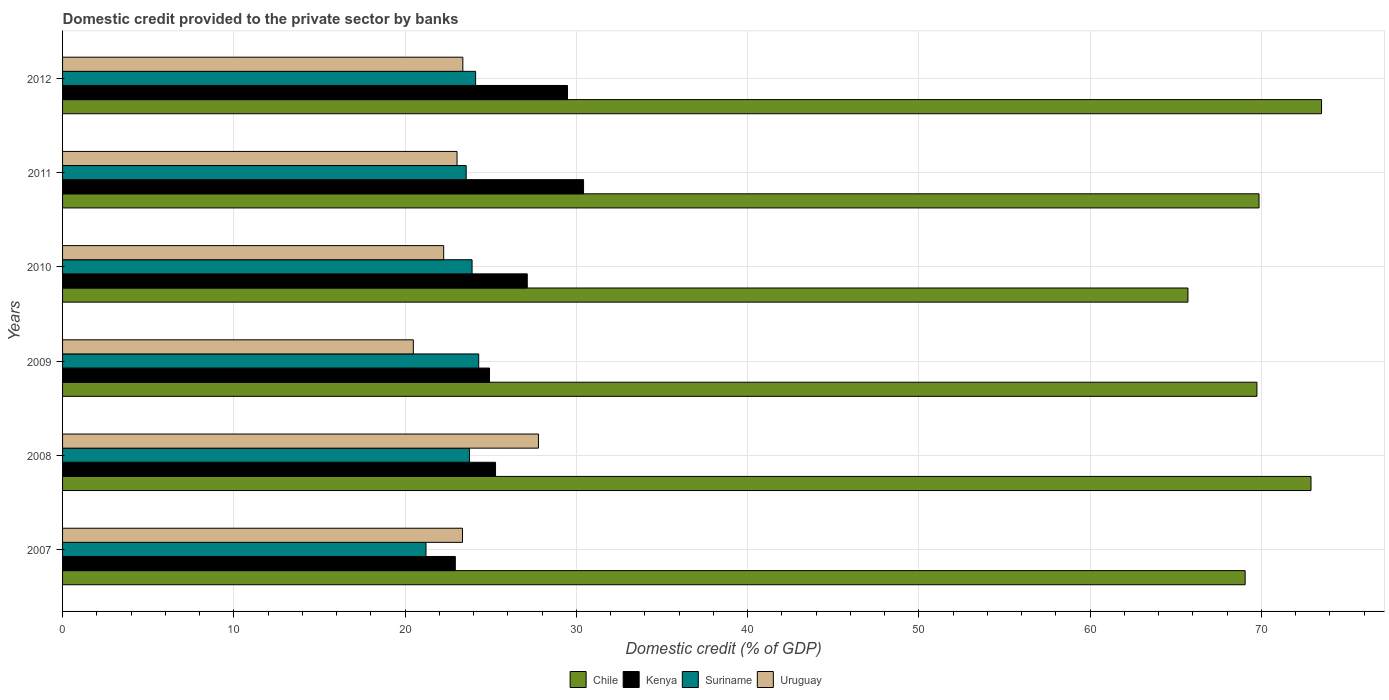Are the number of bars per tick equal to the number of legend labels?
Make the answer very short. Yes. In how many cases, is the number of bars for a given year not equal to the number of legend labels?
Give a very brief answer. 0. What is the domestic credit provided to the private sector by banks in Suriname in 2008?
Give a very brief answer. 23.76. Across all years, what is the maximum domestic credit provided to the private sector by banks in Kenya?
Provide a succinct answer. 30.42. Across all years, what is the minimum domestic credit provided to the private sector by banks in Kenya?
Make the answer very short. 22.93. In which year was the domestic credit provided to the private sector by banks in Chile minimum?
Offer a very short reply. 2010. What is the total domestic credit provided to the private sector by banks in Chile in the graph?
Keep it short and to the point. 420.77. What is the difference between the domestic credit provided to the private sector by banks in Chile in 2008 and that in 2012?
Offer a terse response. -0.62. What is the difference between the domestic credit provided to the private sector by banks in Chile in 2010 and the domestic credit provided to the private sector by banks in Suriname in 2008?
Offer a very short reply. 41.95. What is the average domestic credit provided to the private sector by banks in Suriname per year?
Keep it short and to the point. 23.48. In the year 2012, what is the difference between the domestic credit provided to the private sector by banks in Kenya and domestic credit provided to the private sector by banks in Suriname?
Provide a succinct answer. 5.37. What is the ratio of the domestic credit provided to the private sector by banks in Kenya in 2009 to that in 2011?
Keep it short and to the point. 0.82. Is the domestic credit provided to the private sector by banks in Kenya in 2007 less than that in 2009?
Offer a very short reply. Yes. Is the difference between the domestic credit provided to the private sector by banks in Kenya in 2007 and 2009 greater than the difference between the domestic credit provided to the private sector by banks in Suriname in 2007 and 2009?
Give a very brief answer. Yes. What is the difference between the highest and the second highest domestic credit provided to the private sector by banks in Kenya?
Your response must be concise. 0.94. What is the difference between the highest and the lowest domestic credit provided to the private sector by banks in Uruguay?
Your response must be concise. 7.31. Is it the case that in every year, the sum of the domestic credit provided to the private sector by banks in Uruguay and domestic credit provided to the private sector by banks in Chile is greater than the sum of domestic credit provided to the private sector by banks in Kenya and domestic credit provided to the private sector by banks in Suriname?
Your answer should be very brief. Yes. What does the 4th bar from the top in 2008 represents?
Keep it short and to the point. Chile. What does the 4th bar from the bottom in 2008 represents?
Ensure brevity in your answer.  Uruguay. Is it the case that in every year, the sum of the domestic credit provided to the private sector by banks in Kenya and domestic credit provided to the private sector by banks in Suriname is greater than the domestic credit provided to the private sector by banks in Uruguay?
Provide a short and direct response. Yes. Does the graph contain any zero values?
Provide a short and direct response. No. Does the graph contain grids?
Your response must be concise. Yes. Where does the legend appear in the graph?
Keep it short and to the point. Bottom center. How many legend labels are there?
Offer a terse response. 4. How are the legend labels stacked?
Ensure brevity in your answer.  Horizontal. What is the title of the graph?
Your answer should be compact. Domestic credit provided to the private sector by banks. What is the label or title of the X-axis?
Offer a very short reply. Domestic credit (% of GDP). What is the label or title of the Y-axis?
Your answer should be compact. Years. What is the Domestic credit (% of GDP) of Chile in 2007?
Keep it short and to the point. 69.05. What is the Domestic credit (% of GDP) in Kenya in 2007?
Provide a succinct answer. 22.93. What is the Domestic credit (% of GDP) in Suriname in 2007?
Keep it short and to the point. 21.22. What is the Domestic credit (% of GDP) in Uruguay in 2007?
Your response must be concise. 23.35. What is the Domestic credit (% of GDP) in Chile in 2008?
Your response must be concise. 72.9. What is the Domestic credit (% of GDP) of Kenya in 2008?
Your response must be concise. 25.28. What is the Domestic credit (% of GDP) in Suriname in 2008?
Ensure brevity in your answer.  23.76. What is the Domestic credit (% of GDP) of Uruguay in 2008?
Provide a short and direct response. 27.79. What is the Domestic credit (% of GDP) of Chile in 2009?
Offer a very short reply. 69.74. What is the Domestic credit (% of GDP) of Kenya in 2009?
Provide a succinct answer. 24.93. What is the Domestic credit (% of GDP) in Suriname in 2009?
Provide a short and direct response. 24.3. What is the Domestic credit (% of GDP) of Uruguay in 2009?
Give a very brief answer. 20.48. What is the Domestic credit (% of GDP) of Chile in 2010?
Ensure brevity in your answer.  65.71. What is the Domestic credit (% of GDP) of Kenya in 2010?
Ensure brevity in your answer.  27.13. What is the Domestic credit (% of GDP) in Suriname in 2010?
Provide a short and direct response. 23.91. What is the Domestic credit (% of GDP) of Uruguay in 2010?
Offer a very short reply. 22.25. What is the Domestic credit (% of GDP) in Chile in 2011?
Ensure brevity in your answer.  69.86. What is the Domestic credit (% of GDP) in Kenya in 2011?
Provide a succinct answer. 30.42. What is the Domestic credit (% of GDP) of Suriname in 2011?
Make the answer very short. 23.57. What is the Domestic credit (% of GDP) of Uruguay in 2011?
Give a very brief answer. 23.03. What is the Domestic credit (% of GDP) of Chile in 2012?
Offer a terse response. 73.51. What is the Domestic credit (% of GDP) in Kenya in 2012?
Give a very brief answer. 29.48. What is the Domestic credit (% of GDP) in Suriname in 2012?
Provide a succinct answer. 24.12. What is the Domestic credit (% of GDP) of Uruguay in 2012?
Provide a succinct answer. 23.37. Across all years, what is the maximum Domestic credit (% of GDP) in Chile?
Offer a very short reply. 73.51. Across all years, what is the maximum Domestic credit (% of GDP) of Kenya?
Your answer should be compact. 30.42. Across all years, what is the maximum Domestic credit (% of GDP) of Suriname?
Your response must be concise. 24.3. Across all years, what is the maximum Domestic credit (% of GDP) in Uruguay?
Keep it short and to the point. 27.79. Across all years, what is the minimum Domestic credit (% of GDP) of Chile?
Offer a very short reply. 65.71. Across all years, what is the minimum Domestic credit (% of GDP) of Kenya?
Offer a very short reply. 22.93. Across all years, what is the minimum Domestic credit (% of GDP) in Suriname?
Your response must be concise. 21.22. Across all years, what is the minimum Domestic credit (% of GDP) of Uruguay?
Make the answer very short. 20.48. What is the total Domestic credit (% of GDP) of Chile in the graph?
Your answer should be compact. 420.77. What is the total Domestic credit (% of GDP) in Kenya in the graph?
Your answer should be very brief. 160.18. What is the total Domestic credit (% of GDP) of Suriname in the graph?
Your response must be concise. 140.87. What is the total Domestic credit (% of GDP) in Uruguay in the graph?
Your answer should be very brief. 140.28. What is the difference between the Domestic credit (% of GDP) in Chile in 2007 and that in 2008?
Your answer should be very brief. -3.85. What is the difference between the Domestic credit (% of GDP) in Kenya in 2007 and that in 2008?
Give a very brief answer. -2.35. What is the difference between the Domestic credit (% of GDP) of Suriname in 2007 and that in 2008?
Your answer should be very brief. -2.54. What is the difference between the Domestic credit (% of GDP) of Uruguay in 2007 and that in 2008?
Ensure brevity in your answer.  -4.44. What is the difference between the Domestic credit (% of GDP) in Chile in 2007 and that in 2009?
Your answer should be compact. -0.69. What is the difference between the Domestic credit (% of GDP) in Kenya in 2007 and that in 2009?
Keep it short and to the point. -2. What is the difference between the Domestic credit (% of GDP) of Suriname in 2007 and that in 2009?
Your answer should be compact. -3.08. What is the difference between the Domestic credit (% of GDP) of Uruguay in 2007 and that in 2009?
Ensure brevity in your answer.  2.87. What is the difference between the Domestic credit (% of GDP) of Chile in 2007 and that in 2010?
Offer a very short reply. 3.34. What is the difference between the Domestic credit (% of GDP) in Kenya in 2007 and that in 2010?
Offer a very short reply. -4.2. What is the difference between the Domestic credit (% of GDP) of Suriname in 2007 and that in 2010?
Your response must be concise. -2.69. What is the difference between the Domestic credit (% of GDP) of Uruguay in 2007 and that in 2010?
Offer a very short reply. 1.1. What is the difference between the Domestic credit (% of GDP) in Chile in 2007 and that in 2011?
Give a very brief answer. -0.81. What is the difference between the Domestic credit (% of GDP) of Kenya in 2007 and that in 2011?
Offer a terse response. -7.49. What is the difference between the Domestic credit (% of GDP) in Suriname in 2007 and that in 2011?
Your answer should be compact. -2.35. What is the difference between the Domestic credit (% of GDP) of Uruguay in 2007 and that in 2011?
Give a very brief answer. 0.32. What is the difference between the Domestic credit (% of GDP) of Chile in 2007 and that in 2012?
Provide a succinct answer. -4.46. What is the difference between the Domestic credit (% of GDP) in Kenya in 2007 and that in 2012?
Provide a short and direct response. -6.55. What is the difference between the Domestic credit (% of GDP) in Suriname in 2007 and that in 2012?
Ensure brevity in your answer.  -2.9. What is the difference between the Domestic credit (% of GDP) in Uruguay in 2007 and that in 2012?
Your answer should be compact. -0.02. What is the difference between the Domestic credit (% of GDP) in Chile in 2008 and that in 2009?
Offer a very short reply. 3.16. What is the difference between the Domestic credit (% of GDP) in Kenya in 2008 and that in 2009?
Provide a short and direct response. 0.35. What is the difference between the Domestic credit (% of GDP) in Suriname in 2008 and that in 2009?
Your answer should be very brief. -0.54. What is the difference between the Domestic credit (% of GDP) of Uruguay in 2008 and that in 2009?
Keep it short and to the point. 7.31. What is the difference between the Domestic credit (% of GDP) of Chile in 2008 and that in 2010?
Your response must be concise. 7.18. What is the difference between the Domestic credit (% of GDP) in Kenya in 2008 and that in 2010?
Give a very brief answer. -1.85. What is the difference between the Domestic credit (% of GDP) in Suriname in 2008 and that in 2010?
Ensure brevity in your answer.  -0.15. What is the difference between the Domestic credit (% of GDP) in Uruguay in 2008 and that in 2010?
Provide a succinct answer. 5.53. What is the difference between the Domestic credit (% of GDP) of Chile in 2008 and that in 2011?
Make the answer very short. 3.03. What is the difference between the Domestic credit (% of GDP) in Kenya in 2008 and that in 2011?
Give a very brief answer. -5.14. What is the difference between the Domestic credit (% of GDP) of Suriname in 2008 and that in 2011?
Your answer should be very brief. 0.19. What is the difference between the Domestic credit (% of GDP) of Uruguay in 2008 and that in 2011?
Make the answer very short. 4.75. What is the difference between the Domestic credit (% of GDP) in Chile in 2008 and that in 2012?
Offer a terse response. -0.62. What is the difference between the Domestic credit (% of GDP) of Kenya in 2008 and that in 2012?
Provide a short and direct response. -4.2. What is the difference between the Domestic credit (% of GDP) in Suriname in 2008 and that in 2012?
Offer a very short reply. -0.36. What is the difference between the Domestic credit (% of GDP) of Uruguay in 2008 and that in 2012?
Provide a short and direct response. 4.42. What is the difference between the Domestic credit (% of GDP) of Chile in 2009 and that in 2010?
Make the answer very short. 4.03. What is the difference between the Domestic credit (% of GDP) in Kenya in 2009 and that in 2010?
Your response must be concise. -2.2. What is the difference between the Domestic credit (% of GDP) in Suriname in 2009 and that in 2010?
Keep it short and to the point. 0.39. What is the difference between the Domestic credit (% of GDP) of Uruguay in 2009 and that in 2010?
Provide a succinct answer. -1.77. What is the difference between the Domestic credit (% of GDP) of Chile in 2009 and that in 2011?
Your answer should be compact. -0.12. What is the difference between the Domestic credit (% of GDP) of Kenya in 2009 and that in 2011?
Make the answer very short. -5.49. What is the difference between the Domestic credit (% of GDP) of Suriname in 2009 and that in 2011?
Ensure brevity in your answer.  0.73. What is the difference between the Domestic credit (% of GDP) of Uruguay in 2009 and that in 2011?
Offer a very short reply. -2.55. What is the difference between the Domestic credit (% of GDP) in Chile in 2009 and that in 2012?
Keep it short and to the point. -3.77. What is the difference between the Domestic credit (% of GDP) of Kenya in 2009 and that in 2012?
Offer a terse response. -4.55. What is the difference between the Domestic credit (% of GDP) in Suriname in 2009 and that in 2012?
Ensure brevity in your answer.  0.18. What is the difference between the Domestic credit (% of GDP) of Uruguay in 2009 and that in 2012?
Provide a succinct answer. -2.89. What is the difference between the Domestic credit (% of GDP) in Chile in 2010 and that in 2011?
Provide a succinct answer. -4.15. What is the difference between the Domestic credit (% of GDP) of Kenya in 2010 and that in 2011?
Provide a succinct answer. -3.29. What is the difference between the Domestic credit (% of GDP) in Suriname in 2010 and that in 2011?
Your answer should be very brief. 0.34. What is the difference between the Domestic credit (% of GDP) of Uruguay in 2010 and that in 2011?
Give a very brief answer. -0.78. What is the difference between the Domestic credit (% of GDP) in Chile in 2010 and that in 2012?
Offer a very short reply. -7.8. What is the difference between the Domestic credit (% of GDP) in Kenya in 2010 and that in 2012?
Keep it short and to the point. -2.35. What is the difference between the Domestic credit (% of GDP) in Suriname in 2010 and that in 2012?
Your answer should be compact. -0.21. What is the difference between the Domestic credit (% of GDP) of Uruguay in 2010 and that in 2012?
Your response must be concise. -1.12. What is the difference between the Domestic credit (% of GDP) in Chile in 2011 and that in 2012?
Keep it short and to the point. -3.65. What is the difference between the Domestic credit (% of GDP) in Kenya in 2011 and that in 2012?
Offer a very short reply. 0.94. What is the difference between the Domestic credit (% of GDP) of Suriname in 2011 and that in 2012?
Your response must be concise. -0.55. What is the difference between the Domestic credit (% of GDP) in Uruguay in 2011 and that in 2012?
Offer a very short reply. -0.34. What is the difference between the Domestic credit (% of GDP) in Chile in 2007 and the Domestic credit (% of GDP) in Kenya in 2008?
Your response must be concise. 43.77. What is the difference between the Domestic credit (% of GDP) of Chile in 2007 and the Domestic credit (% of GDP) of Suriname in 2008?
Make the answer very short. 45.29. What is the difference between the Domestic credit (% of GDP) in Chile in 2007 and the Domestic credit (% of GDP) in Uruguay in 2008?
Make the answer very short. 41.26. What is the difference between the Domestic credit (% of GDP) in Kenya in 2007 and the Domestic credit (% of GDP) in Suriname in 2008?
Provide a succinct answer. -0.82. What is the difference between the Domestic credit (% of GDP) in Kenya in 2007 and the Domestic credit (% of GDP) in Uruguay in 2008?
Offer a terse response. -4.85. What is the difference between the Domestic credit (% of GDP) of Suriname in 2007 and the Domestic credit (% of GDP) of Uruguay in 2008?
Offer a very short reply. -6.57. What is the difference between the Domestic credit (% of GDP) of Chile in 2007 and the Domestic credit (% of GDP) of Kenya in 2009?
Offer a very short reply. 44.12. What is the difference between the Domestic credit (% of GDP) in Chile in 2007 and the Domestic credit (% of GDP) in Suriname in 2009?
Your answer should be compact. 44.75. What is the difference between the Domestic credit (% of GDP) of Chile in 2007 and the Domestic credit (% of GDP) of Uruguay in 2009?
Make the answer very short. 48.57. What is the difference between the Domestic credit (% of GDP) of Kenya in 2007 and the Domestic credit (% of GDP) of Suriname in 2009?
Offer a very short reply. -1.36. What is the difference between the Domestic credit (% of GDP) in Kenya in 2007 and the Domestic credit (% of GDP) in Uruguay in 2009?
Make the answer very short. 2.45. What is the difference between the Domestic credit (% of GDP) of Suriname in 2007 and the Domestic credit (% of GDP) of Uruguay in 2009?
Offer a terse response. 0.74. What is the difference between the Domestic credit (% of GDP) in Chile in 2007 and the Domestic credit (% of GDP) in Kenya in 2010?
Offer a terse response. 41.92. What is the difference between the Domestic credit (% of GDP) in Chile in 2007 and the Domestic credit (% of GDP) in Suriname in 2010?
Your answer should be compact. 45.14. What is the difference between the Domestic credit (% of GDP) in Chile in 2007 and the Domestic credit (% of GDP) in Uruguay in 2010?
Provide a short and direct response. 46.8. What is the difference between the Domestic credit (% of GDP) in Kenya in 2007 and the Domestic credit (% of GDP) in Suriname in 2010?
Make the answer very short. -0.98. What is the difference between the Domestic credit (% of GDP) in Kenya in 2007 and the Domestic credit (% of GDP) in Uruguay in 2010?
Offer a very short reply. 0.68. What is the difference between the Domestic credit (% of GDP) in Suriname in 2007 and the Domestic credit (% of GDP) in Uruguay in 2010?
Your response must be concise. -1.03. What is the difference between the Domestic credit (% of GDP) of Chile in 2007 and the Domestic credit (% of GDP) of Kenya in 2011?
Ensure brevity in your answer.  38.63. What is the difference between the Domestic credit (% of GDP) of Chile in 2007 and the Domestic credit (% of GDP) of Suriname in 2011?
Make the answer very short. 45.48. What is the difference between the Domestic credit (% of GDP) in Chile in 2007 and the Domestic credit (% of GDP) in Uruguay in 2011?
Provide a short and direct response. 46.02. What is the difference between the Domestic credit (% of GDP) in Kenya in 2007 and the Domestic credit (% of GDP) in Suriname in 2011?
Provide a succinct answer. -0.63. What is the difference between the Domestic credit (% of GDP) of Kenya in 2007 and the Domestic credit (% of GDP) of Uruguay in 2011?
Ensure brevity in your answer.  -0.1. What is the difference between the Domestic credit (% of GDP) of Suriname in 2007 and the Domestic credit (% of GDP) of Uruguay in 2011?
Give a very brief answer. -1.81. What is the difference between the Domestic credit (% of GDP) in Chile in 2007 and the Domestic credit (% of GDP) in Kenya in 2012?
Ensure brevity in your answer.  39.57. What is the difference between the Domestic credit (% of GDP) in Chile in 2007 and the Domestic credit (% of GDP) in Suriname in 2012?
Your answer should be compact. 44.93. What is the difference between the Domestic credit (% of GDP) in Chile in 2007 and the Domestic credit (% of GDP) in Uruguay in 2012?
Offer a very short reply. 45.68. What is the difference between the Domestic credit (% of GDP) of Kenya in 2007 and the Domestic credit (% of GDP) of Suriname in 2012?
Give a very brief answer. -1.19. What is the difference between the Domestic credit (% of GDP) of Kenya in 2007 and the Domestic credit (% of GDP) of Uruguay in 2012?
Your answer should be very brief. -0.44. What is the difference between the Domestic credit (% of GDP) in Suriname in 2007 and the Domestic credit (% of GDP) in Uruguay in 2012?
Your response must be concise. -2.15. What is the difference between the Domestic credit (% of GDP) in Chile in 2008 and the Domestic credit (% of GDP) in Kenya in 2009?
Provide a short and direct response. 47.97. What is the difference between the Domestic credit (% of GDP) of Chile in 2008 and the Domestic credit (% of GDP) of Suriname in 2009?
Provide a succinct answer. 48.6. What is the difference between the Domestic credit (% of GDP) in Chile in 2008 and the Domestic credit (% of GDP) in Uruguay in 2009?
Give a very brief answer. 52.41. What is the difference between the Domestic credit (% of GDP) of Kenya in 2008 and the Domestic credit (% of GDP) of Suriname in 2009?
Provide a short and direct response. 0.98. What is the difference between the Domestic credit (% of GDP) in Kenya in 2008 and the Domestic credit (% of GDP) in Uruguay in 2009?
Your answer should be very brief. 4.8. What is the difference between the Domestic credit (% of GDP) in Suriname in 2008 and the Domestic credit (% of GDP) in Uruguay in 2009?
Your answer should be very brief. 3.28. What is the difference between the Domestic credit (% of GDP) in Chile in 2008 and the Domestic credit (% of GDP) in Kenya in 2010?
Keep it short and to the point. 45.76. What is the difference between the Domestic credit (% of GDP) in Chile in 2008 and the Domestic credit (% of GDP) in Suriname in 2010?
Your answer should be very brief. 48.98. What is the difference between the Domestic credit (% of GDP) in Chile in 2008 and the Domestic credit (% of GDP) in Uruguay in 2010?
Give a very brief answer. 50.64. What is the difference between the Domestic credit (% of GDP) of Kenya in 2008 and the Domestic credit (% of GDP) of Suriname in 2010?
Your response must be concise. 1.37. What is the difference between the Domestic credit (% of GDP) of Kenya in 2008 and the Domestic credit (% of GDP) of Uruguay in 2010?
Provide a succinct answer. 3.03. What is the difference between the Domestic credit (% of GDP) in Suriname in 2008 and the Domestic credit (% of GDP) in Uruguay in 2010?
Your answer should be compact. 1.5. What is the difference between the Domestic credit (% of GDP) in Chile in 2008 and the Domestic credit (% of GDP) in Kenya in 2011?
Your answer should be very brief. 42.47. What is the difference between the Domestic credit (% of GDP) in Chile in 2008 and the Domestic credit (% of GDP) in Suriname in 2011?
Offer a very short reply. 49.33. What is the difference between the Domestic credit (% of GDP) of Chile in 2008 and the Domestic credit (% of GDP) of Uruguay in 2011?
Your answer should be compact. 49.86. What is the difference between the Domestic credit (% of GDP) in Kenya in 2008 and the Domestic credit (% of GDP) in Suriname in 2011?
Offer a very short reply. 1.71. What is the difference between the Domestic credit (% of GDP) of Kenya in 2008 and the Domestic credit (% of GDP) of Uruguay in 2011?
Your response must be concise. 2.25. What is the difference between the Domestic credit (% of GDP) in Suriname in 2008 and the Domestic credit (% of GDP) in Uruguay in 2011?
Your answer should be compact. 0.72. What is the difference between the Domestic credit (% of GDP) in Chile in 2008 and the Domestic credit (% of GDP) in Kenya in 2012?
Provide a short and direct response. 43.41. What is the difference between the Domestic credit (% of GDP) in Chile in 2008 and the Domestic credit (% of GDP) in Suriname in 2012?
Your answer should be very brief. 48.78. What is the difference between the Domestic credit (% of GDP) of Chile in 2008 and the Domestic credit (% of GDP) of Uruguay in 2012?
Offer a very short reply. 49.52. What is the difference between the Domestic credit (% of GDP) of Kenya in 2008 and the Domestic credit (% of GDP) of Suriname in 2012?
Offer a terse response. 1.16. What is the difference between the Domestic credit (% of GDP) of Kenya in 2008 and the Domestic credit (% of GDP) of Uruguay in 2012?
Your answer should be very brief. 1.91. What is the difference between the Domestic credit (% of GDP) in Suriname in 2008 and the Domestic credit (% of GDP) in Uruguay in 2012?
Keep it short and to the point. 0.39. What is the difference between the Domestic credit (% of GDP) in Chile in 2009 and the Domestic credit (% of GDP) in Kenya in 2010?
Your response must be concise. 42.6. What is the difference between the Domestic credit (% of GDP) of Chile in 2009 and the Domestic credit (% of GDP) of Suriname in 2010?
Provide a short and direct response. 45.83. What is the difference between the Domestic credit (% of GDP) in Chile in 2009 and the Domestic credit (% of GDP) in Uruguay in 2010?
Your answer should be compact. 47.49. What is the difference between the Domestic credit (% of GDP) of Kenya in 2009 and the Domestic credit (% of GDP) of Suriname in 2010?
Offer a very short reply. 1.02. What is the difference between the Domestic credit (% of GDP) in Kenya in 2009 and the Domestic credit (% of GDP) in Uruguay in 2010?
Your answer should be compact. 2.68. What is the difference between the Domestic credit (% of GDP) of Suriname in 2009 and the Domestic credit (% of GDP) of Uruguay in 2010?
Your response must be concise. 2.04. What is the difference between the Domestic credit (% of GDP) of Chile in 2009 and the Domestic credit (% of GDP) of Kenya in 2011?
Your response must be concise. 39.32. What is the difference between the Domestic credit (% of GDP) in Chile in 2009 and the Domestic credit (% of GDP) in Suriname in 2011?
Make the answer very short. 46.17. What is the difference between the Domestic credit (% of GDP) in Chile in 2009 and the Domestic credit (% of GDP) in Uruguay in 2011?
Your response must be concise. 46.71. What is the difference between the Domestic credit (% of GDP) in Kenya in 2009 and the Domestic credit (% of GDP) in Suriname in 2011?
Your answer should be compact. 1.36. What is the difference between the Domestic credit (% of GDP) in Kenya in 2009 and the Domestic credit (% of GDP) in Uruguay in 2011?
Offer a terse response. 1.9. What is the difference between the Domestic credit (% of GDP) of Suriname in 2009 and the Domestic credit (% of GDP) of Uruguay in 2011?
Make the answer very short. 1.26. What is the difference between the Domestic credit (% of GDP) of Chile in 2009 and the Domestic credit (% of GDP) of Kenya in 2012?
Ensure brevity in your answer.  40.25. What is the difference between the Domestic credit (% of GDP) in Chile in 2009 and the Domestic credit (% of GDP) in Suriname in 2012?
Provide a succinct answer. 45.62. What is the difference between the Domestic credit (% of GDP) of Chile in 2009 and the Domestic credit (% of GDP) of Uruguay in 2012?
Offer a terse response. 46.37. What is the difference between the Domestic credit (% of GDP) of Kenya in 2009 and the Domestic credit (% of GDP) of Suriname in 2012?
Provide a short and direct response. 0.81. What is the difference between the Domestic credit (% of GDP) of Kenya in 2009 and the Domestic credit (% of GDP) of Uruguay in 2012?
Provide a succinct answer. 1.56. What is the difference between the Domestic credit (% of GDP) in Suriname in 2009 and the Domestic credit (% of GDP) in Uruguay in 2012?
Offer a very short reply. 0.93. What is the difference between the Domestic credit (% of GDP) in Chile in 2010 and the Domestic credit (% of GDP) in Kenya in 2011?
Offer a very short reply. 35.29. What is the difference between the Domestic credit (% of GDP) of Chile in 2010 and the Domestic credit (% of GDP) of Suriname in 2011?
Give a very brief answer. 42.14. What is the difference between the Domestic credit (% of GDP) of Chile in 2010 and the Domestic credit (% of GDP) of Uruguay in 2011?
Offer a very short reply. 42.68. What is the difference between the Domestic credit (% of GDP) in Kenya in 2010 and the Domestic credit (% of GDP) in Suriname in 2011?
Your answer should be compact. 3.57. What is the difference between the Domestic credit (% of GDP) of Kenya in 2010 and the Domestic credit (% of GDP) of Uruguay in 2011?
Your answer should be compact. 4.1. What is the difference between the Domestic credit (% of GDP) in Suriname in 2010 and the Domestic credit (% of GDP) in Uruguay in 2011?
Keep it short and to the point. 0.88. What is the difference between the Domestic credit (% of GDP) in Chile in 2010 and the Domestic credit (% of GDP) in Kenya in 2012?
Give a very brief answer. 36.23. What is the difference between the Domestic credit (% of GDP) in Chile in 2010 and the Domestic credit (% of GDP) in Suriname in 2012?
Give a very brief answer. 41.59. What is the difference between the Domestic credit (% of GDP) in Chile in 2010 and the Domestic credit (% of GDP) in Uruguay in 2012?
Offer a terse response. 42.34. What is the difference between the Domestic credit (% of GDP) in Kenya in 2010 and the Domestic credit (% of GDP) in Suriname in 2012?
Keep it short and to the point. 3.01. What is the difference between the Domestic credit (% of GDP) in Kenya in 2010 and the Domestic credit (% of GDP) in Uruguay in 2012?
Provide a succinct answer. 3.76. What is the difference between the Domestic credit (% of GDP) in Suriname in 2010 and the Domestic credit (% of GDP) in Uruguay in 2012?
Ensure brevity in your answer.  0.54. What is the difference between the Domestic credit (% of GDP) in Chile in 2011 and the Domestic credit (% of GDP) in Kenya in 2012?
Make the answer very short. 40.38. What is the difference between the Domestic credit (% of GDP) in Chile in 2011 and the Domestic credit (% of GDP) in Suriname in 2012?
Your response must be concise. 45.74. What is the difference between the Domestic credit (% of GDP) in Chile in 2011 and the Domestic credit (% of GDP) in Uruguay in 2012?
Your answer should be very brief. 46.49. What is the difference between the Domestic credit (% of GDP) of Kenya in 2011 and the Domestic credit (% of GDP) of Suriname in 2012?
Provide a succinct answer. 6.3. What is the difference between the Domestic credit (% of GDP) of Kenya in 2011 and the Domestic credit (% of GDP) of Uruguay in 2012?
Your response must be concise. 7.05. What is the difference between the Domestic credit (% of GDP) in Suriname in 2011 and the Domestic credit (% of GDP) in Uruguay in 2012?
Keep it short and to the point. 0.2. What is the average Domestic credit (% of GDP) of Chile per year?
Ensure brevity in your answer.  70.13. What is the average Domestic credit (% of GDP) in Kenya per year?
Your answer should be very brief. 26.7. What is the average Domestic credit (% of GDP) of Suriname per year?
Make the answer very short. 23.48. What is the average Domestic credit (% of GDP) of Uruguay per year?
Your answer should be very brief. 23.38. In the year 2007, what is the difference between the Domestic credit (% of GDP) in Chile and Domestic credit (% of GDP) in Kenya?
Provide a short and direct response. 46.12. In the year 2007, what is the difference between the Domestic credit (% of GDP) of Chile and Domestic credit (% of GDP) of Suriname?
Provide a succinct answer. 47.83. In the year 2007, what is the difference between the Domestic credit (% of GDP) of Chile and Domestic credit (% of GDP) of Uruguay?
Ensure brevity in your answer.  45.7. In the year 2007, what is the difference between the Domestic credit (% of GDP) of Kenya and Domestic credit (% of GDP) of Suriname?
Ensure brevity in your answer.  1.71. In the year 2007, what is the difference between the Domestic credit (% of GDP) in Kenya and Domestic credit (% of GDP) in Uruguay?
Your answer should be compact. -0.42. In the year 2007, what is the difference between the Domestic credit (% of GDP) in Suriname and Domestic credit (% of GDP) in Uruguay?
Keep it short and to the point. -2.13. In the year 2008, what is the difference between the Domestic credit (% of GDP) in Chile and Domestic credit (% of GDP) in Kenya?
Your answer should be compact. 47.61. In the year 2008, what is the difference between the Domestic credit (% of GDP) of Chile and Domestic credit (% of GDP) of Suriname?
Provide a short and direct response. 49.14. In the year 2008, what is the difference between the Domestic credit (% of GDP) in Chile and Domestic credit (% of GDP) in Uruguay?
Offer a terse response. 45.11. In the year 2008, what is the difference between the Domestic credit (% of GDP) in Kenya and Domestic credit (% of GDP) in Suriname?
Your response must be concise. 1.52. In the year 2008, what is the difference between the Domestic credit (% of GDP) of Kenya and Domestic credit (% of GDP) of Uruguay?
Keep it short and to the point. -2.51. In the year 2008, what is the difference between the Domestic credit (% of GDP) in Suriname and Domestic credit (% of GDP) in Uruguay?
Keep it short and to the point. -4.03. In the year 2009, what is the difference between the Domestic credit (% of GDP) of Chile and Domestic credit (% of GDP) of Kenya?
Your response must be concise. 44.81. In the year 2009, what is the difference between the Domestic credit (% of GDP) in Chile and Domestic credit (% of GDP) in Suriname?
Offer a very short reply. 45.44. In the year 2009, what is the difference between the Domestic credit (% of GDP) in Chile and Domestic credit (% of GDP) in Uruguay?
Ensure brevity in your answer.  49.26. In the year 2009, what is the difference between the Domestic credit (% of GDP) of Kenya and Domestic credit (% of GDP) of Suriname?
Make the answer very short. 0.63. In the year 2009, what is the difference between the Domestic credit (% of GDP) of Kenya and Domestic credit (% of GDP) of Uruguay?
Your answer should be very brief. 4.45. In the year 2009, what is the difference between the Domestic credit (% of GDP) in Suriname and Domestic credit (% of GDP) in Uruguay?
Provide a succinct answer. 3.82. In the year 2010, what is the difference between the Domestic credit (% of GDP) in Chile and Domestic credit (% of GDP) in Kenya?
Make the answer very short. 38.58. In the year 2010, what is the difference between the Domestic credit (% of GDP) in Chile and Domestic credit (% of GDP) in Suriname?
Keep it short and to the point. 41.8. In the year 2010, what is the difference between the Domestic credit (% of GDP) in Chile and Domestic credit (% of GDP) in Uruguay?
Give a very brief answer. 43.46. In the year 2010, what is the difference between the Domestic credit (% of GDP) of Kenya and Domestic credit (% of GDP) of Suriname?
Make the answer very short. 3.22. In the year 2010, what is the difference between the Domestic credit (% of GDP) in Kenya and Domestic credit (% of GDP) in Uruguay?
Keep it short and to the point. 4.88. In the year 2010, what is the difference between the Domestic credit (% of GDP) of Suriname and Domestic credit (% of GDP) of Uruguay?
Your answer should be very brief. 1.66. In the year 2011, what is the difference between the Domestic credit (% of GDP) in Chile and Domestic credit (% of GDP) in Kenya?
Provide a short and direct response. 39.44. In the year 2011, what is the difference between the Domestic credit (% of GDP) of Chile and Domestic credit (% of GDP) of Suriname?
Provide a succinct answer. 46.29. In the year 2011, what is the difference between the Domestic credit (% of GDP) of Chile and Domestic credit (% of GDP) of Uruguay?
Your answer should be compact. 46.83. In the year 2011, what is the difference between the Domestic credit (% of GDP) of Kenya and Domestic credit (% of GDP) of Suriname?
Offer a terse response. 6.85. In the year 2011, what is the difference between the Domestic credit (% of GDP) in Kenya and Domestic credit (% of GDP) in Uruguay?
Your answer should be very brief. 7.39. In the year 2011, what is the difference between the Domestic credit (% of GDP) in Suriname and Domestic credit (% of GDP) in Uruguay?
Your response must be concise. 0.53. In the year 2012, what is the difference between the Domestic credit (% of GDP) in Chile and Domestic credit (% of GDP) in Kenya?
Ensure brevity in your answer.  44.03. In the year 2012, what is the difference between the Domestic credit (% of GDP) of Chile and Domestic credit (% of GDP) of Suriname?
Offer a very short reply. 49.39. In the year 2012, what is the difference between the Domestic credit (% of GDP) in Chile and Domestic credit (% of GDP) in Uruguay?
Your response must be concise. 50.14. In the year 2012, what is the difference between the Domestic credit (% of GDP) in Kenya and Domestic credit (% of GDP) in Suriname?
Provide a succinct answer. 5.37. In the year 2012, what is the difference between the Domestic credit (% of GDP) of Kenya and Domestic credit (% of GDP) of Uruguay?
Offer a terse response. 6.11. In the year 2012, what is the difference between the Domestic credit (% of GDP) in Suriname and Domestic credit (% of GDP) in Uruguay?
Your response must be concise. 0.75. What is the ratio of the Domestic credit (% of GDP) in Chile in 2007 to that in 2008?
Offer a very short reply. 0.95. What is the ratio of the Domestic credit (% of GDP) of Kenya in 2007 to that in 2008?
Provide a short and direct response. 0.91. What is the ratio of the Domestic credit (% of GDP) of Suriname in 2007 to that in 2008?
Offer a very short reply. 0.89. What is the ratio of the Domestic credit (% of GDP) of Uruguay in 2007 to that in 2008?
Keep it short and to the point. 0.84. What is the ratio of the Domestic credit (% of GDP) of Kenya in 2007 to that in 2009?
Provide a succinct answer. 0.92. What is the ratio of the Domestic credit (% of GDP) in Suriname in 2007 to that in 2009?
Your answer should be very brief. 0.87. What is the ratio of the Domestic credit (% of GDP) in Uruguay in 2007 to that in 2009?
Give a very brief answer. 1.14. What is the ratio of the Domestic credit (% of GDP) of Chile in 2007 to that in 2010?
Offer a terse response. 1.05. What is the ratio of the Domestic credit (% of GDP) of Kenya in 2007 to that in 2010?
Make the answer very short. 0.85. What is the ratio of the Domestic credit (% of GDP) of Suriname in 2007 to that in 2010?
Offer a terse response. 0.89. What is the ratio of the Domestic credit (% of GDP) in Uruguay in 2007 to that in 2010?
Ensure brevity in your answer.  1.05. What is the ratio of the Domestic credit (% of GDP) of Chile in 2007 to that in 2011?
Your answer should be very brief. 0.99. What is the ratio of the Domestic credit (% of GDP) of Kenya in 2007 to that in 2011?
Offer a very short reply. 0.75. What is the ratio of the Domestic credit (% of GDP) in Suriname in 2007 to that in 2011?
Provide a succinct answer. 0.9. What is the ratio of the Domestic credit (% of GDP) in Uruguay in 2007 to that in 2011?
Your response must be concise. 1.01. What is the ratio of the Domestic credit (% of GDP) in Chile in 2007 to that in 2012?
Offer a very short reply. 0.94. What is the ratio of the Domestic credit (% of GDP) in Suriname in 2007 to that in 2012?
Provide a short and direct response. 0.88. What is the ratio of the Domestic credit (% of GDP) of Chile in 2008 to that in 2009?
Provide a succinct answer. 1.05. What is the ratio of the Domestic credit (% of GDP) in Kenya in 2008 to that in 2009?
Provide a succinct answer. 1.01. What is the ratio of the Domestic credit (% of GDP) in Suriname in 2008 to that in 2009?
Offer a terse response. 0.98. What is the ratio of the Domestic credit (% of GDP) in Uruguay in 2008 to that in 2009?
Offer a very short reply. 1.36. What is the ratio of the Domestic credit (% of GDP) of Chile in 2008 to that in 2010?
Your answer should be compact. 1.11. What is the ratio of the Domestic credit (% of GDP) of Kenya in 2008 to that in 2010?
Ensure brevity in your answer.  0.93. What is the ratio of the Domestic credit (% of GDP) in Uruguay in 2008 to that in 2010?
Give a very brief answer. 1.25. What is the ratio of the Domestic credit (% of GDP) of Chile in 2008 to that in 2011?
Your response must be concise. 1.04. What is the ratio of the Domestic credit (% of GDP) of Kenya in 2008 to that in 2011?
Keep it short and to the point. 0.83. What is the ratio of the Domestic credit (% of GDP) of Suriname in 2008 to that in 2011?
Your answer should be compact. 1.01. What is the ratio of the Domestic credit (% of GDP) of Uruguay in 2008 to that in 2011?
Your answer should be very brief. 1.21. What is the ratio of the Domestic credit (% of GDP) in Kenya in 2008 to that in 2012?
Your answer should be very brief. 0.86. What is the ratio of the Domestic credit (% of GDP) in Uruguay in 2008 to that in 2012?
Make the answer very short. 1.19. What is the ratio of the Domestic credit (% of GDP) in Chile in 2009 to that in 2010?
Provide a succinct answer. 1.06. What is the ratio of the Domestic credit (% of GDP) in Kenya in 2009 to that in 2010?
Provide a succinct answer. 0.92. What is the ratio of the Domestic credit (% of GDP) in Suriname in 2009 to that in 2010?
Your response must be concise. 1.02. What is the ratio of the Domestic credit (% of GDP) in Uruguay in 2009 to that in 2010?
Make the answer very short. 0.92. What is the ratio of the Domestic credit (% of GDP) of Kenya in 2009 to that in 2011?
Keep it short and to the point. 0.82. What is the ratio of the Domestic credit (% of GDP) of Suriname in 2009 to that in 2011?
Provide a short and direct response. 1.03. What is the ratio of the Domestic credit (% of GDP) in Uruguay in 2009 to that in 2011?
Give a very brief answer. 0.89. What is the ratio of the Domestic credit (% of GDP) of Chile in 2009 to that in 2012?
Offer a terse response. 0.95. What is the ratio of the Domestic credit (% of GDP) of Kenya in 2009 to that in 2012?
Offer a very short reply. 0.85. What is the ratio of the Domestic credit (% of GDP) of Suriname in 2009 to that in 2012?
Give a very brief answer. 1.01. What is the ratio of the Domestic credit (% of GDP) of Uruguay in 2009 to that in 2012?
Keep it short and to the point. 0.88. What is the ratio of the Domestic credit (% of GDP) in Chile in 2010 to that in 2011?
Give a very brief answer. 0.94. What is the ratio of the Domestic credit (% of GDP) in Kenya in 2010 to that in 2011?
Provide a succinct answer. 0.89. What is the ratio of the Domestic credit (% of GDP) of Suriname in 2010 to that in 2011?
Provide a short and direct response. 1.01. What is the ratio of the Domestic credit (% of GDP) in Uruguay in 2010 to that in 2011?
Your answer should be very brief. 0.97. What is the ratio of the Domestic credit (% of GDP) of Chile in 2010 to that in 2012?
Keep it short and to the point. 0.89. What is the ratio of the Domestic credit (% of GDP) of Kenya in 2010 to that in 2012?
Ensure brevity in your answer.  0.92. What is the ratio of the Domestic credit (% of GDP) in Suriname in 2010 to that in 2012?
Your answer should be compact. 0.99. What is the ratio of the Domestic credit (% of GDP) in Uruguay in 2010 to that in 2012?
Provide a short and direct response. 0.95. What is the ratio of the Domestic credit (% of GDP) in Chile in 2011 to that in 2012?
Make the answer very short. 0.95. What is the ratio of the Domestic credit (% of GDP) of Kenya in 2011 to that in 2012?
Your response must be concise. 1.03. What is the ratio of the Domestic credit (% of GDP) in Suriname in 2011 to that in 2012?
Give a very brief answer. 0.98. What is the ratio of the Domestic credit (% of GDP) in Uruguay in 2011 to that in 2012?
Your answer should be compact. 0.99. What is the difference between the highest and the second highest Domestic credit (% of GDP) in Chile?
Provide a short and direct response. 0.62. What is the difference between the highest and the second highest Domestic credit (% of GDP) of Kenya?
Keep it short and to the point. 0.94. What is the difference between the highest and the second highest Domestic credit (% of GDP) of Suriname?
Give a very brief answer. 0.18. What is the difference between the highest and the second highest Domestic credit (% of GDP) in Uruguay?
Offer a very short reply. 4.42. What is the difference between the highest and the lowest Domestic credit (% of GDP) of Chile?
Offer a terse response. 7.8. What is the difference between the highest and the lowest Domestic credit (% of GDP) in Kenya?
Offer a very short reply. 7.49. What is the difference between the highest and the lowest Domestic credit (% of GDP) of Suriname?
Offer a terse response. 3.08. What is the difference between the highest and the lowest Domestic credit (% of GDP) of Uruguay?
Give a very brief answer. 7.31. 